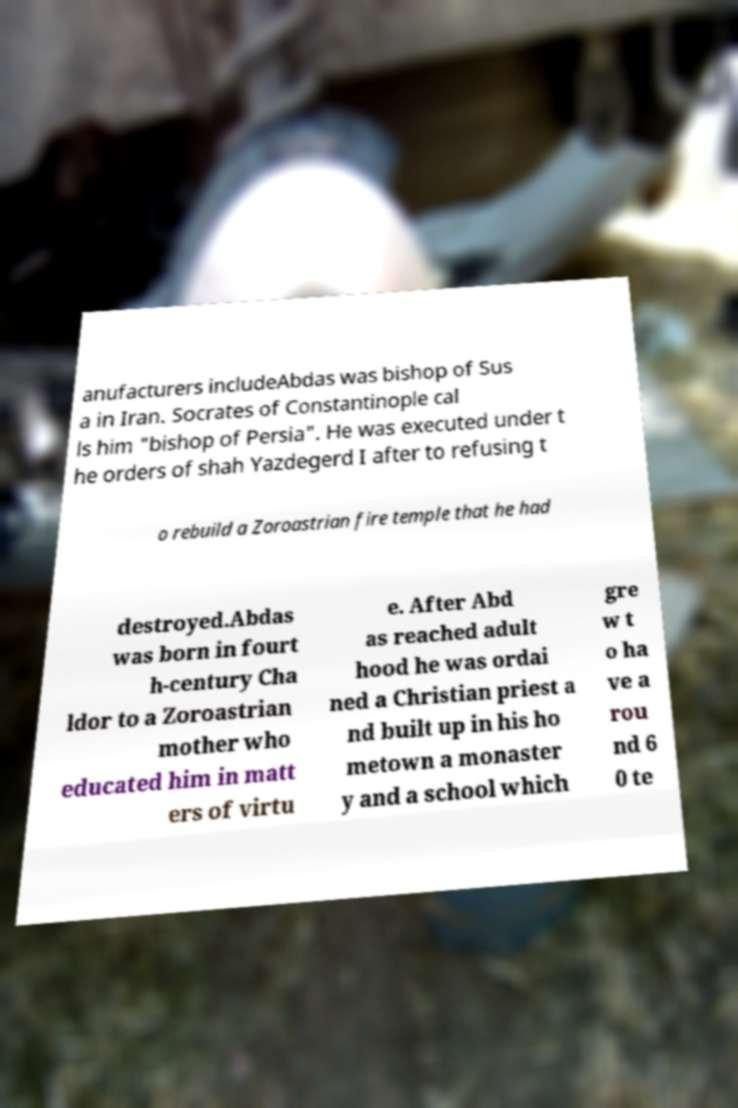I need the written content from this picture converted into text. Can you do that? anufacturers includeAbdas was bishop of Sus a in Iran. Socrates of Constantinople cal ls him "bishop of Persia". He was executed under t he orders of shah Yazdegerd I after to refusing t o rebuild a Zoroastrian fire temple that he had destroyed.Abdas was born in fourt h-century Cha ldor to a Zoroastrian mother who educated him in matt ers of virtu e. After Abd as reached adult hood he was ordai ned a Christian priest a nd built up in his ho metown a monaster y and a school which gre w t o ha ve a rou nd 6 0 te 